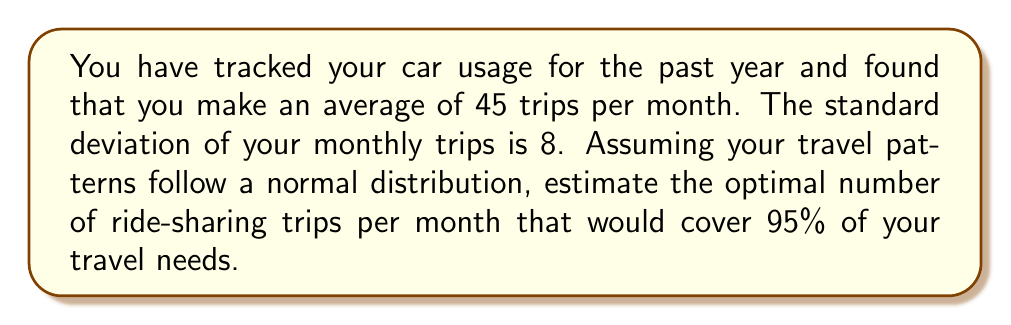Could you help me with this problem? To solve this inverse problem, we need to use the properties of the normal distribution and the concept of confidence intervals. Here's a step-by-step approach:

1) In a normal distribution, approximately 95% of the data falls within 2 standard deviations of the mean.

2) Let $\mu$ be the mean number of trips and $\sigma$ be the standard deviation.
   Given: $\mu = 45$ and $\sigma = 8$

3) To cover 95% of travel needs, we need to find the value that is 2 standard deviations above the mean:

   $\text{Optimal number of trips} = \mu + 2\sigma$

4) Substituting the values:

   $\text{Optimal number of trips} = 45 + 2(8) = 45 + 16 = 61$

5) Since we can't have a fractional number of trips, we round up to the nearest whole number to ensure we cover at least 95% of travel needs.

Therefore, the optimal number of ride-sharing trips per month to cover 95% of travel needs is 61.
Answer: 61 trips per month 